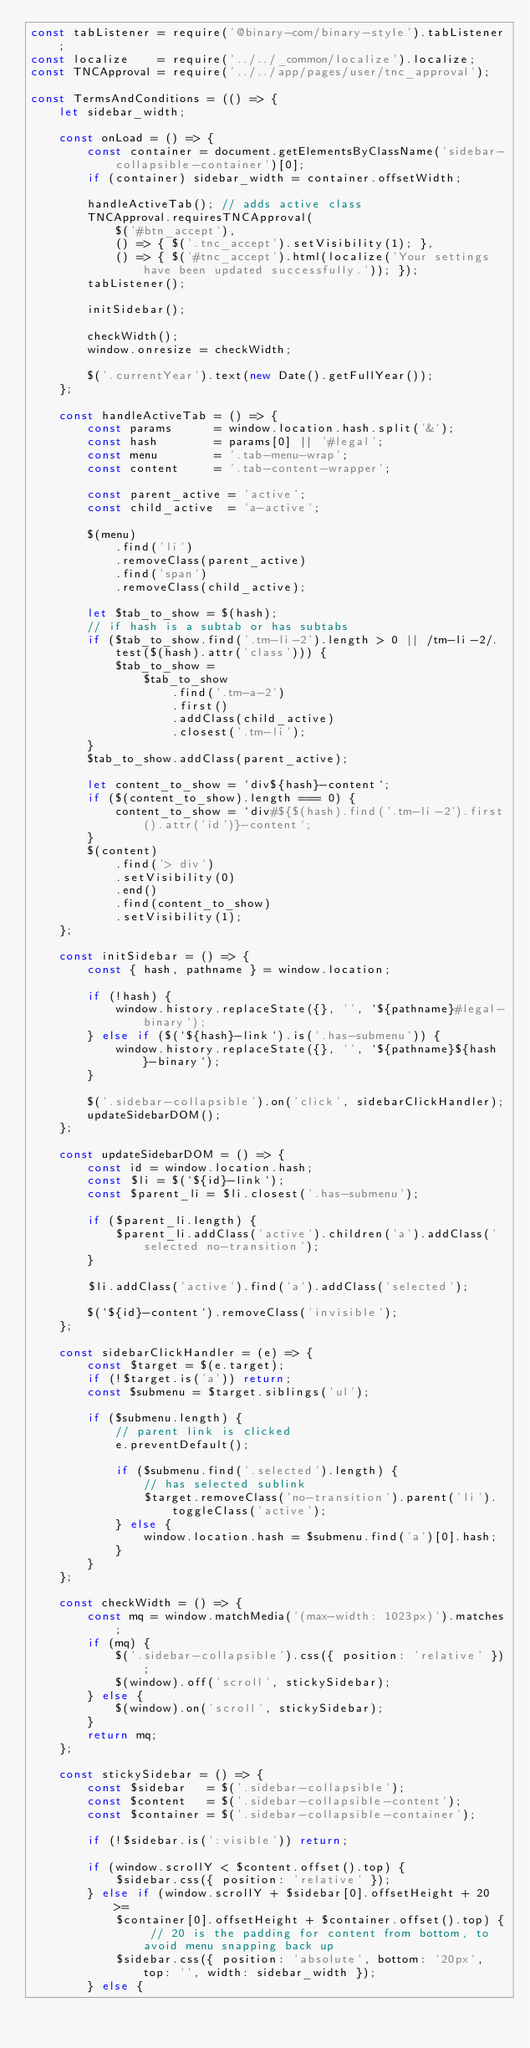Convert code to text. <code><loc_0><loc_0><loc_500><loc_500><_JavaScript_>const tabListener = require('@binary-com/binary-style').tabListener;
const localize    = require('../../_common/localize').localize;
const TNCApproval = require('../../app/pages/user/tnc_approval');

const TermsAndConditions = (() => {
    let sidebar_width;

    const onLoad = () => {
        const container = document.getElementsByClassName('sidebar-collapsible-container')[0];
        if (container) sidebar_width = container.offsetWidth;

        handleActiveTab(); // adds active class
        TNCApproval.requiresTNCApproval(
            $('#btn_accept'),
            () => { $('.tnc_accept').setVisibility(1); },
            () => { $('#tnc_accept').html(localize('Your settings have been updated successfully.')); });
        tabListener();

        initSidebar();

        checkWidth();
        window.onresize = checkWidth;

        $('.currentYear').text(new Date().getFullYear());
    };

    const handleActiveTab = () => {
        const params      = window.location.hash.split('&');
        const hash        = params[0] || '#legal';
        const menu        = '.tab-menu-wrap';
        const content     = '.tab-content-wrapper';

        const parent_active = 'active';
        const child_active  = 'a-active';

        $(menu)
            .find('li')
            .removeClass(parent_active)
            .find('span')
            .removeClass(child_active);

        let $tab_to_show = $(hash);
        // if hash is a subtab or has subtabs
        if ($tab_to_show.find('.tm-li-2').length > 0 || /tm-li-2/.test($(hash).attr('class'))) {
            $tab_to_show =
                $tab_to_show
                    .find('.tm-a-2')
                    .first()
                    .addClass(child_active)
                    .closest('.tm-li');
        }
        $tab_to_show.addClass(parent_active);

        let content_to_show = `div${hash}-content`;
        if ($(content_to_show).length === 0) {
            content_to_show = `div#${$(hash).find('.tm-li-2').first().attr('id')}-content`;
        }
        $(content)
            .find('> div')
            .setVisibility(0)
            .end()
            .find(content_to_show)
            .setVisibility(1);
    };

    const initSidebar = () => {
        const { hash, pathname } = window.location;

        if (!hash) {
            window.history.replaceState({}, '', `${pathname}#legal-binary`);
        } else if ($(`${hash}-link`).is('.has-submenu')) {
            window.history.replaceState({}, '', `${pathname}${hash}-binary`);
        }

        $('.sidebar-collapsible').on('click', sidebarClickHandler);
        updateSidebarDOM();
    };

    const updateSidebarDOM = () => {
        const id = window.location.hash;
        const $li = $(`${id}-link`);
        const $parent_li = $li.closest('.has-submenu');

        if ($parent_li.length) {
            $parent_li.addClass('active').children('a').addClass('selected no-transition');
        }

        $li.addClass('active').find('a').addClass('selected');

        $(`${id}-content`).removeClass('invisible');
    };

    const sidebarClickHandler = (e) => {
        const $target = $(e.target);
        if (!$target.is('a')) return;
        const $submenu = $target.siblings('ul');

        if ($submenu.length) {
            // parent link is clicked
            e.preventDefault();

            if ($submenu.find('.selected').length) {
                // has selected sublink
                $target.removeClass('no-transition').parent('li').toggleClass('active');
            } else {
                window.location.hash = $submenu.find('a')[0].hash;
            }
        }
    };

    const checkWidth = () => {
        const mq = window.matchMedia('(max-width: 1023px)').matches;
        if (mq) {
            $('.sidebar-collapsible').css({ position: 'relative' });
            $(window).off('scroll', stickySidebar);
        } else {
            $(window).on('scroll', stickySidebar);
        }
        return mq;
    };

    const stickySidebar = () => {
        const $sidebar   = $('.sidebar-collapsible');
        const $content   = $('.sidebar-collapsible-content');
        const $container = $('.sidebar-collapsible-container');

        if (!$sidebar.is(':visible')) return;

        if (window.scrollY < $content.offset().top) {
            $sidebar.css({ position: 'relative' });
        } else if (window.scrollY + $sidebar[0].offsetHeight + 20 >=
            $container[0].offsetHeight + $container.offset().top) { // 20 is the padding for content from bottom, to avoid menu snapping back up
            $sidebar.css({ position: 'absolute', bottom: '20px', top: '', width: sidebar_width });
        } else {</code> 